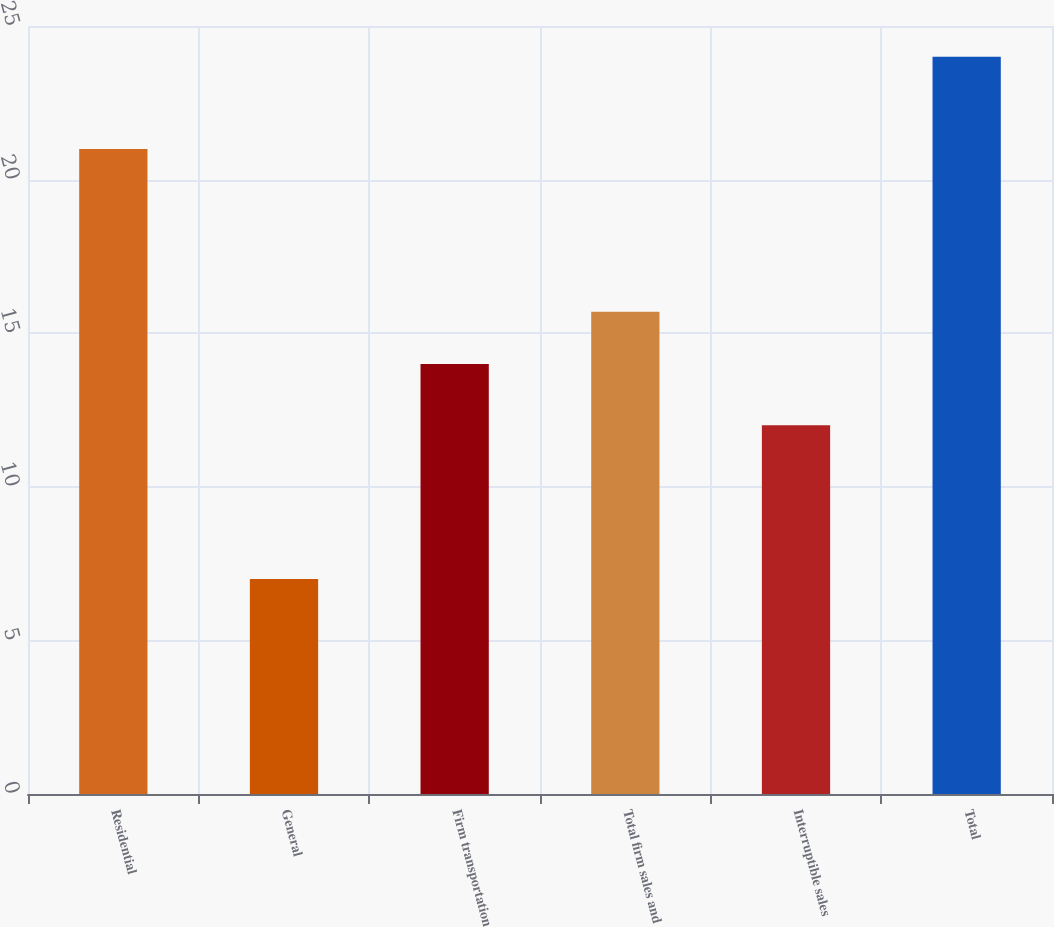Convert chart. <chart><loc_0><loc_0><loc_500><loc_500><bar_chart><fcel>Residential<fcel>General<fcel>Firm transportation<fcel>Total firm sales and<fcel>Interruptible sales<fcel>Total<nl><fcel>21<fcel>7<fcel>14<fcel>15.7<fcel>12<fcel>24<nl></chart> 